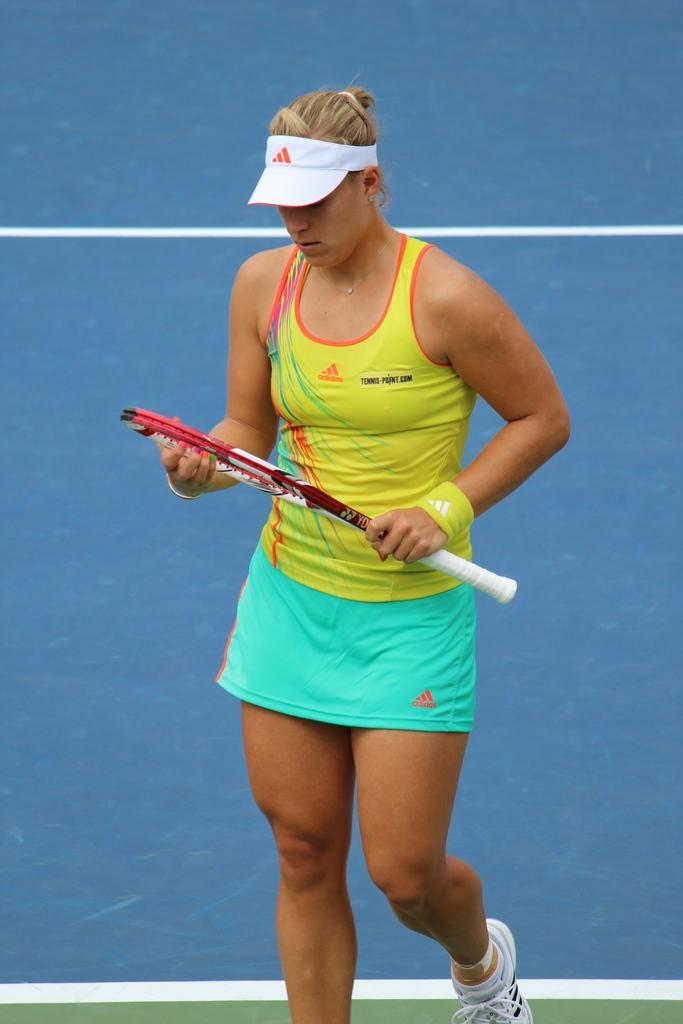Can you describe this image briefly? As we can see in the image there is a woman. 